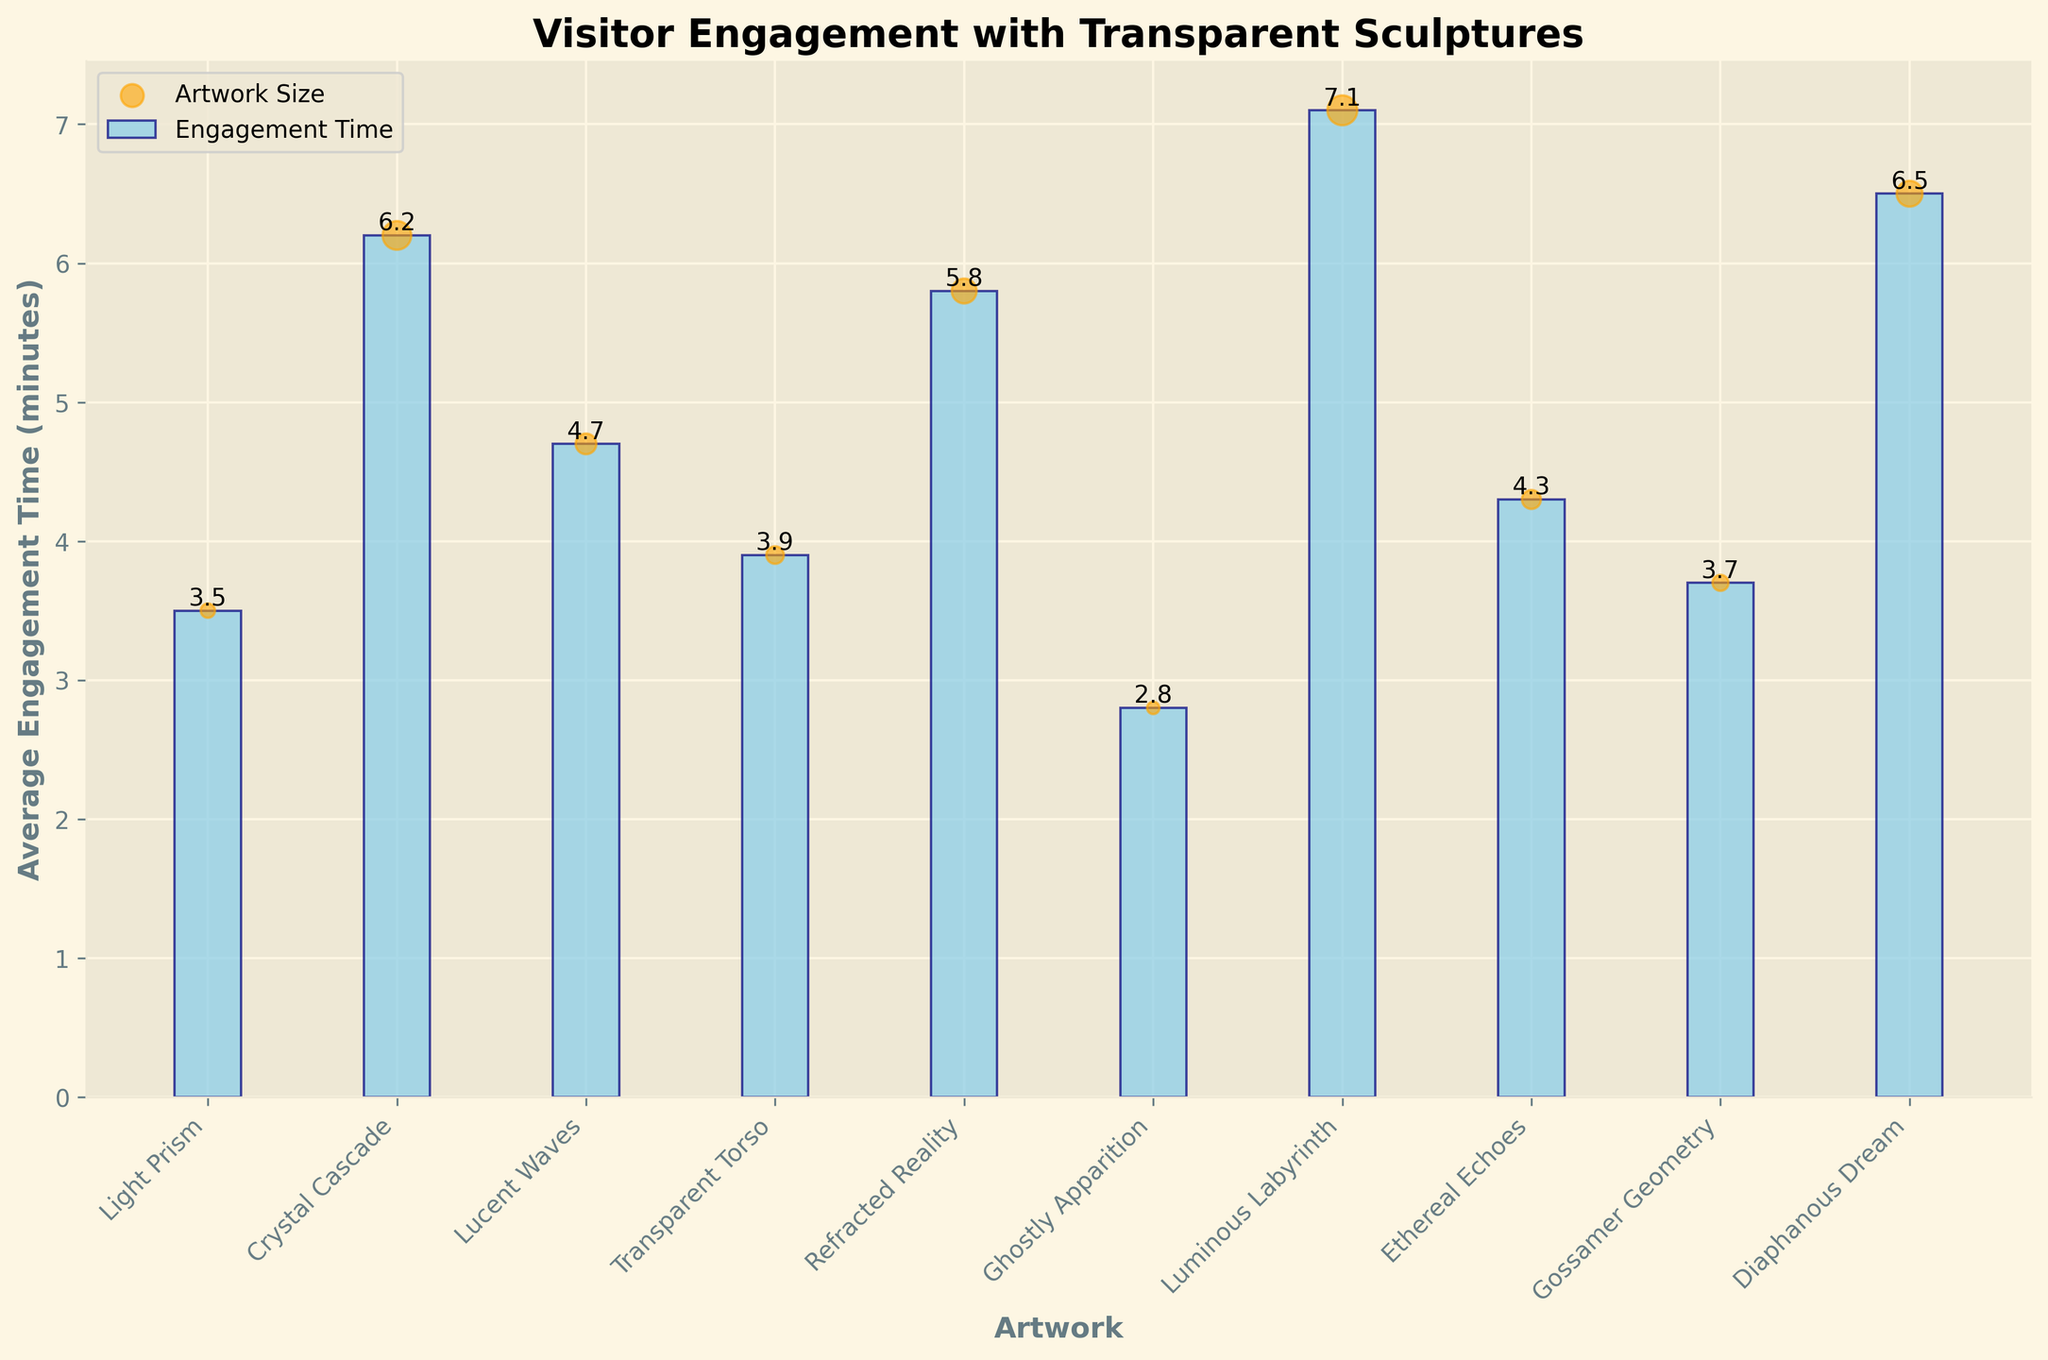Which artwork has the highest visitor engagement time? To find this, look for the bar that has the greatest height.
Answer: Luminous Labyrinth What is the average engagement time for the artworks "Light Prism" and "Transparent Torso"? The average of 3.5 minutes (Light Prism) and 3.9 minutes (Transparent Torso) is calculated as (3.5 + 3.9) / 2 = 3.7 minutes.
Answer: 3.7 minutes Which artwork has the smallest size, and what is its engagement time? Identify the smallest scatter point based on the size (orange circles). The smallest size is 0.9 m³ for "Ghostly Apparition" with an engagement time of 2.8 minutes.
Answer: Ghostly Apparition, 2.8 minutes What is the total engagement time for the two artworks with sizes larger than 5.0 m³? The two artworks are "Luminous Labyrinth" (7.1 minutes) and "Crystal Cascade" (6.2 minutes). The total time is 7.1 + 6.2 = 13.3 minutes.
Answer: 13.3 minutes How does the engagement time for "Refracted Reality" compare to "Lucent Waves"? Check the heights of the bars for both artworks. "Refracted Reality" has an engagement time of 5.8 minutes while "Lucent Waves" has 4.7 minutes.
Answer: Refracted Reality has a longer engagement time Which artwork has the closest engagement time to "Diaphanous Dream"? Compare the heights of the bars and find which one is closest to the 6.5 minutes of "Diaphanous Dream". "Crystal Cascade" is the closest with 6.2 minutes.
Answer: Crystal Cascade What is the range of engagement times for all displayed artworks? Subtract the smallest engagement time from the largest. The range is 7.1 (Luminous Labyrinth) - 2.8 (Ghostly Apparition) = 4.3 minutes.
Answer: 4.3 minutes How do the sizes of "Ethereal Echoes" and "Lucent Waves" compare? Look at the sizes represented by the size of the scatter points. "Lucent Waves" is 2.5 m³ and "Ethereal Echoes" is 2.1 m³.
Answer: Lucent Waves is larger than Ethereal Echoes What is the total engagement time for all artworks with sizes less than 2.0 m³? The artworks are "Light Prism" (3.5), "Transparent Torso" (3.9), "Ghostly Apparition" (2.8), and "Gossamer Geometry" (3.7). The total is 3.5 + 3.9 + 2.8 + 3.7 = 13.9 minutes.
Answer: 13.9 minutes 